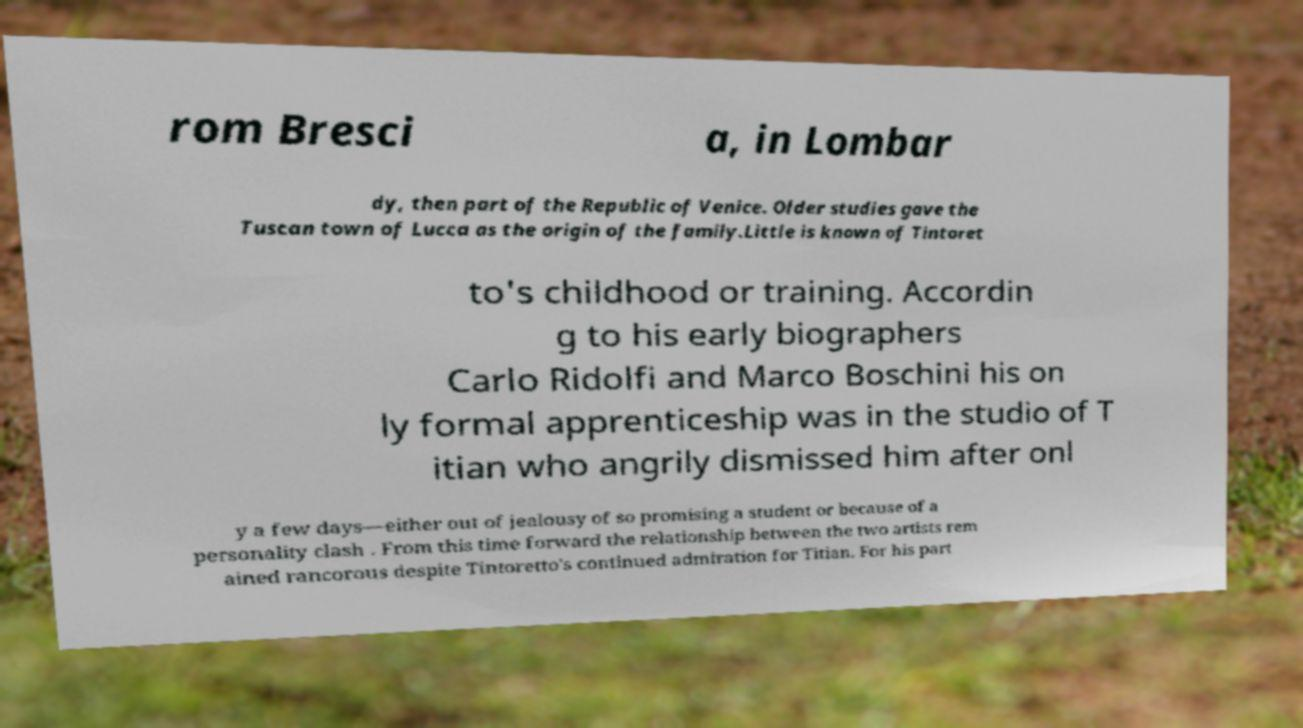Could you extract and type out the text from this image? rom Bresci a, in Lombar dy, then part of the Republic of Venice. Older studies gave the Tuscan town of Lucca as the origin of the family.Little is known of Tintoret to's childhood or training. Accordin g to his early biographers Carlo Ridolfi and Marco Boschini his on ly formal apprenticeship was in the studio of T itian who angrily dismissed him after onl y a few days—either out of jealousy of so promising a student or because of a personality clash . From this time forward the relationship between the two artists rem ained rancorous despite Tintoretto's continued admiration for Titian. For his part 